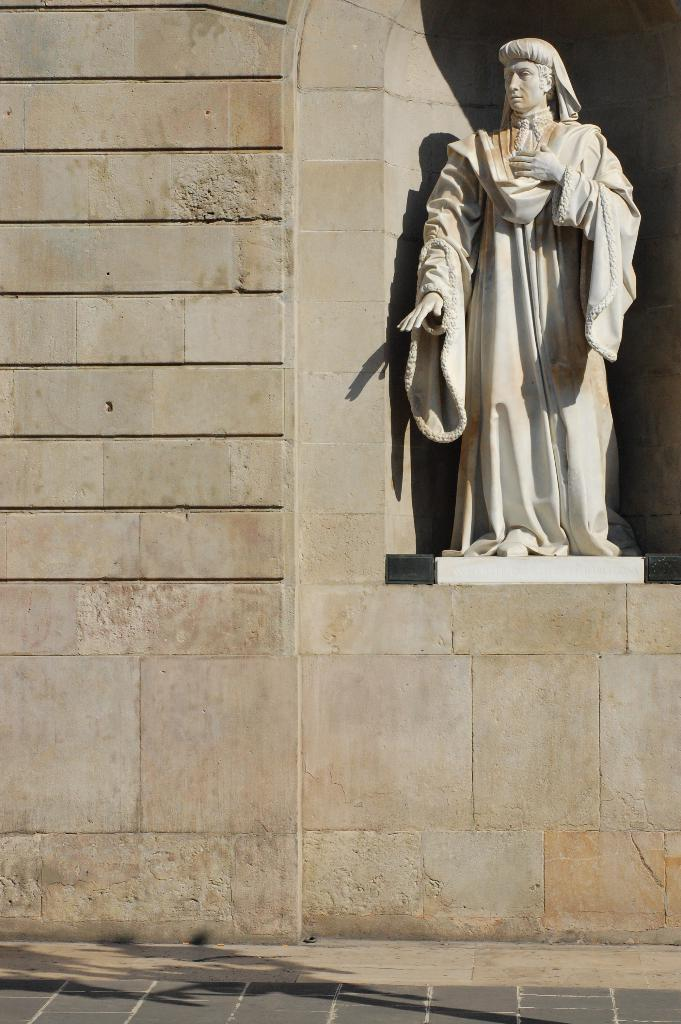What is on the wall of the building in the image? There is a white color statue on the wall of a building. Can you describe any other elements in the image? There is a shadow of an object on the footpath. Where is the cactus located in the image? There is no cactus present in the image. What type of smoke can be seen coming from the statue in the image? There is no smoke present in the image; it only features a white color statue and a shadow on the footpath. 